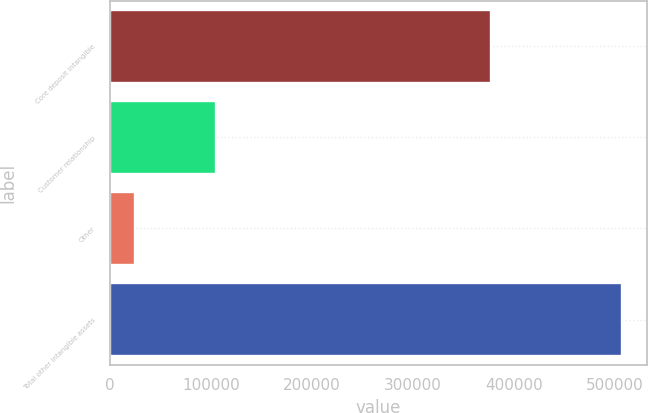Convert chart to OTSL. <chart><loc_0><loc_0><loc_500><loc_500><bar_chart><fcel>Core deposit intangible<fcel>Customer relationship<fcel>Other<fcel>Total other intangible assets<nl><fcel>376846<fcel>104574<fcel>25164<fcel>506584<nl></chart> 